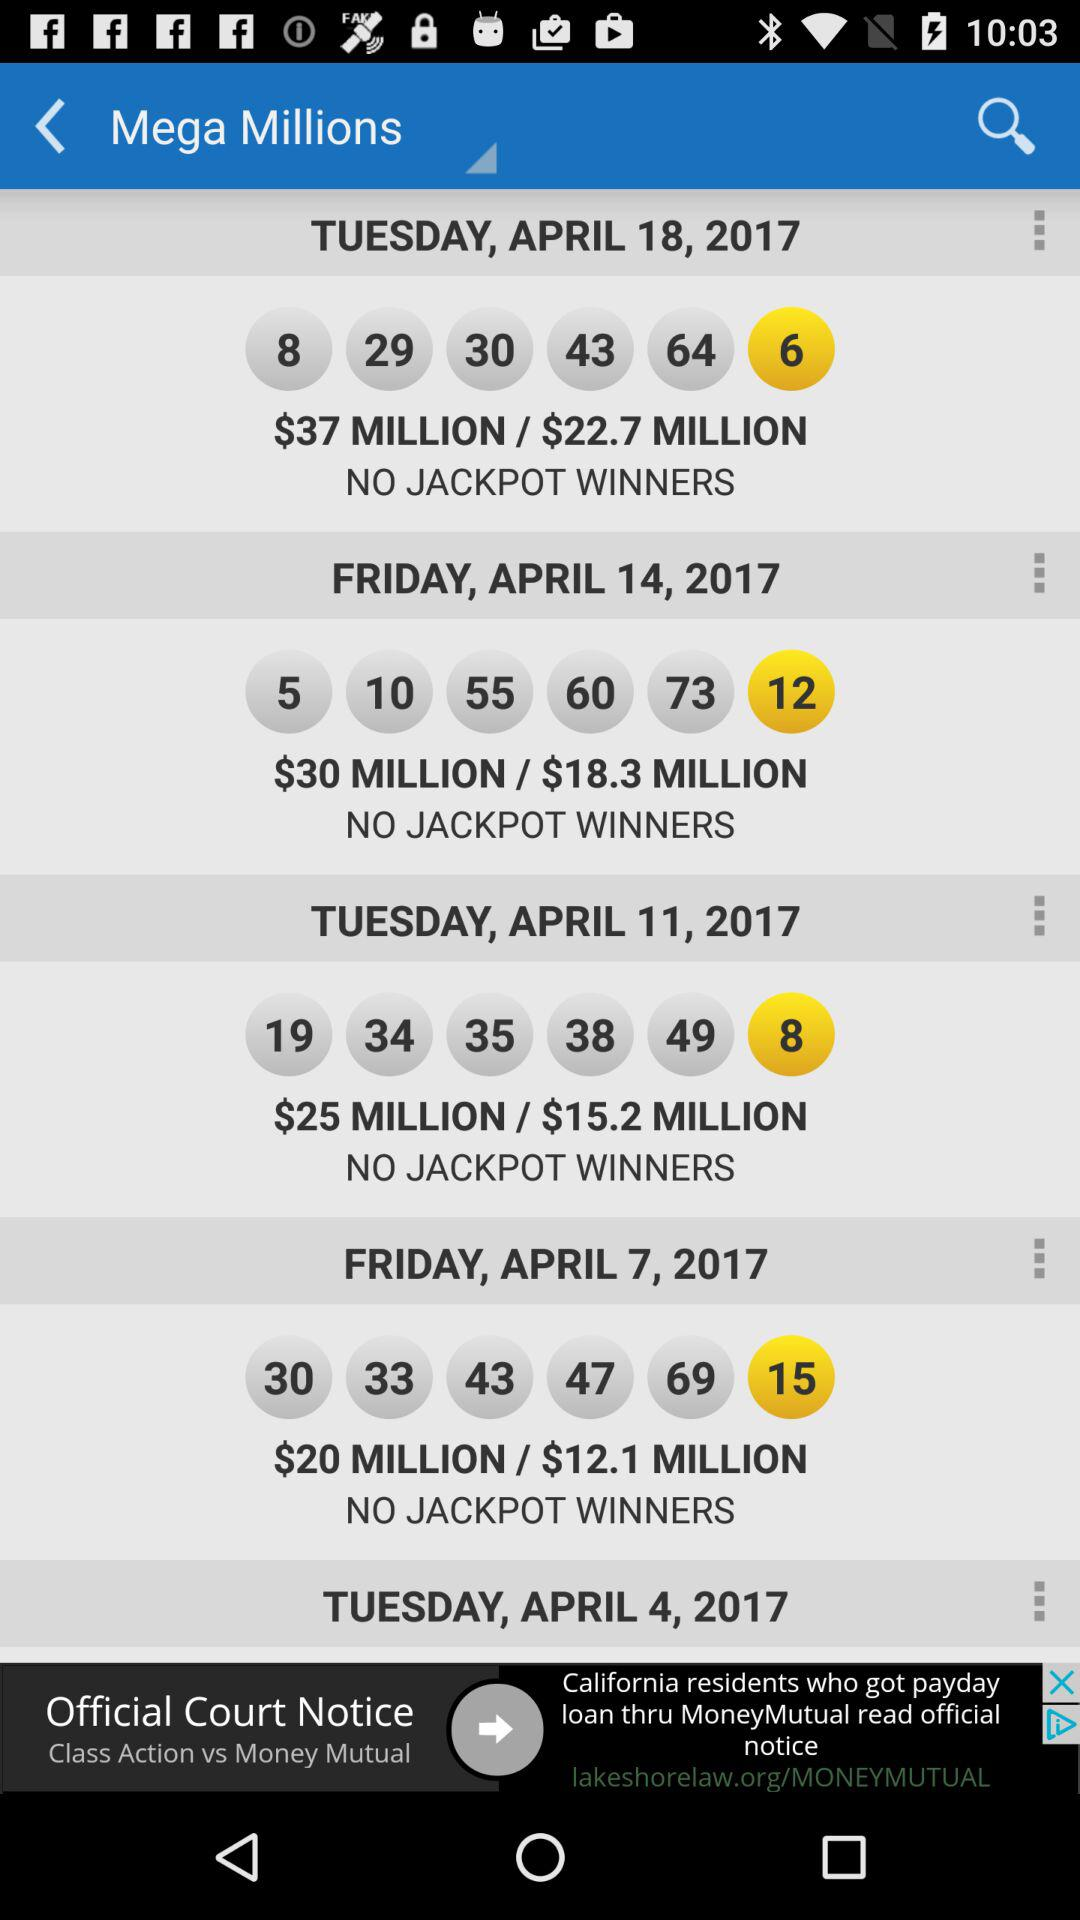Are there any jackpot winners on April 18, 2017? There are no jackpot winners on April 18, 2017. 